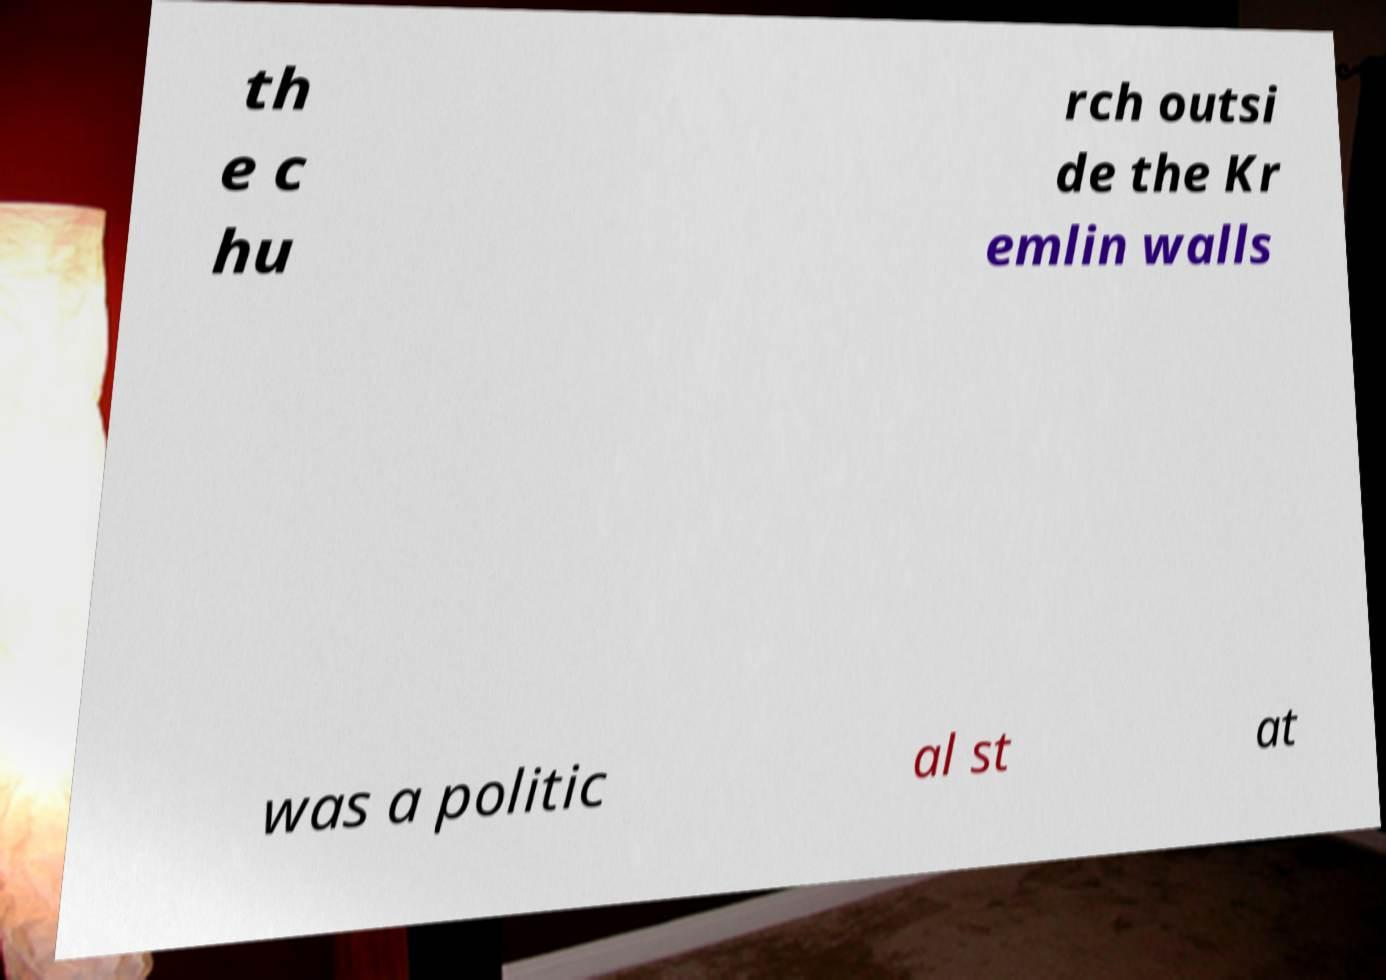What messages or text are displayed in this image? I need them in a readable, typed format. th e c hu rch outsi de the Kr emlin walls was a politic al st at 